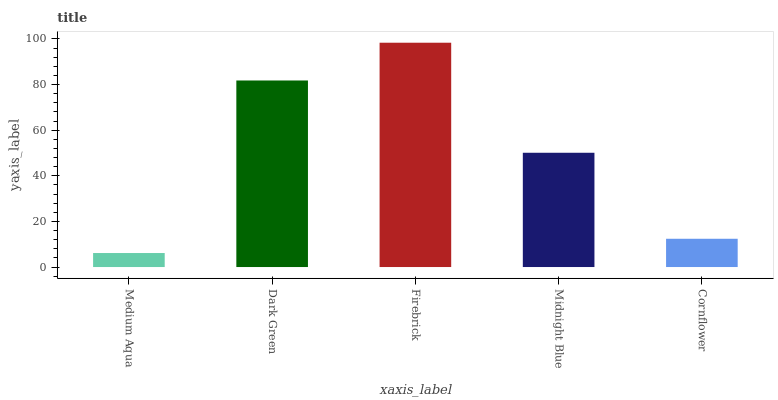Is Medium Aqua the minimum?
Answer yes or no. Yes. Is Firebrick the maximum?
Answer yes or no. Yes. Is Dark Green the minimum?
Answer yes or no. No. Is Dark Green the maximum?
Answer yes or no. No. Is Dark Green greater than Medium Aqua?
Answer yes or no. Yes. Is Medium Aqua less than Dark Green?
Answer yes or no. Yes. Is Medium Aqua greater than Dark Green?
Answer yes or no. No. Is Dark Green less than Medium Aqua?
Answer yes or no. No. Is Midnight Blue the high median?
Answer yes or no. Yes. Is Midnight Blue the low median?
Answer yes or no. Yes. Is Medium Aqua the high median?
Answer yes or no. No. Is Firebrick the low median?
Answer yes or no. No. 